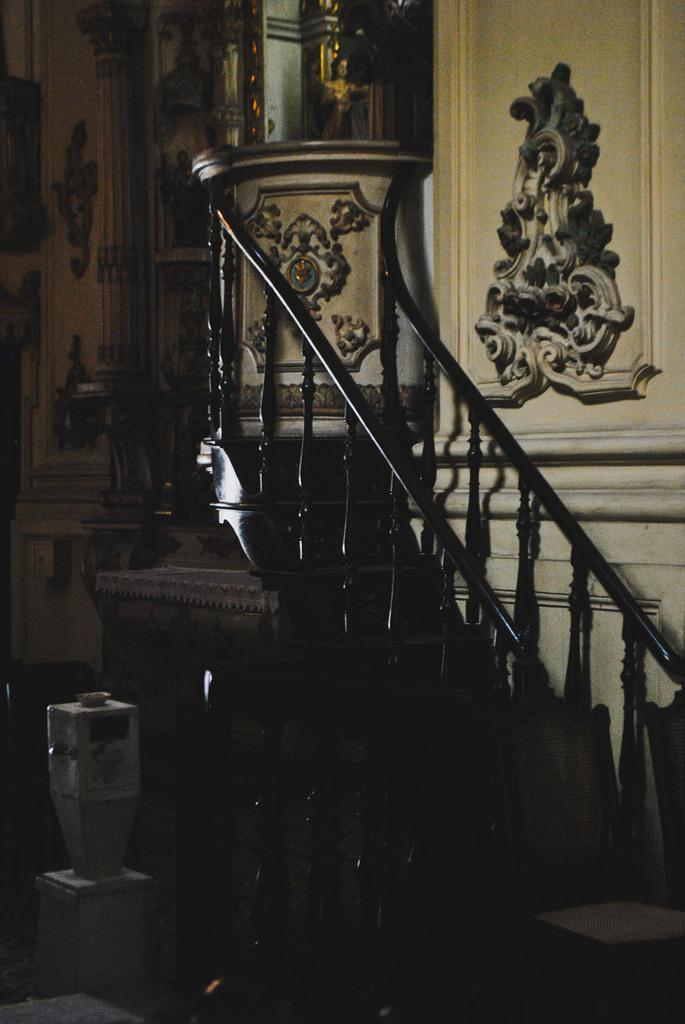What type of location is depicted in the image? The image is an inside view of a building. What can be seen inside the building? There is an idol in the image. Are there any architectural features visible in the image? Yes, there is a staircase in the image. What is the plot of the story unfolding in the image? There is no story or plot depicted in the image; it is a static scene of an inside view of a building with an idol and a staircase. 